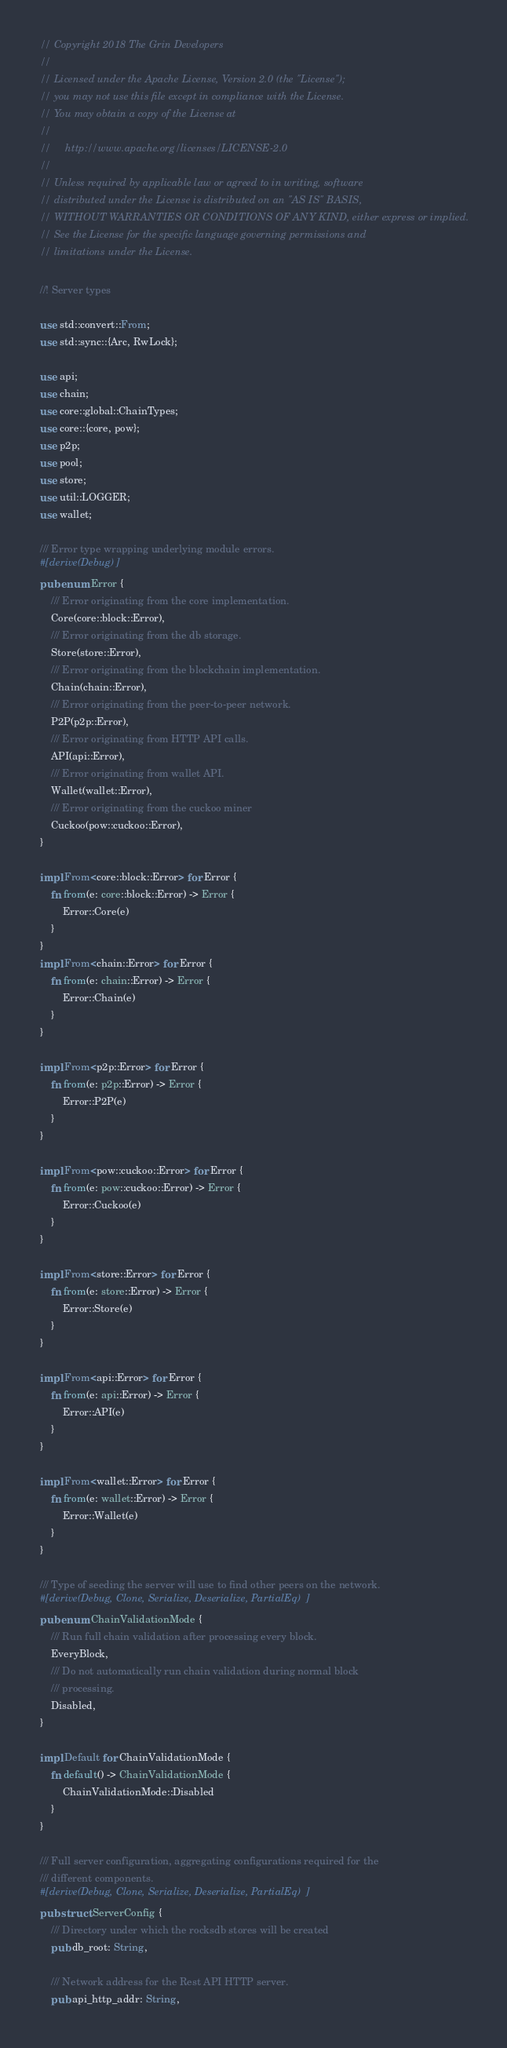<code> <loc_0><loc_0><loc_500><loc_500><_Rust_>// Copyright 2018 The Grin Developers
//
// Licensed under the Apache License, Version 2.0 (the "License");
// you may not use this file except in compliance with the License.
// You may obtain a copy of the License at
//
//     http://www.apache.org/licenses/LICENSE-2.0
//
// Unless required by applicable law or agreed to in writing, software
// distributed under the License is distributed on an "AS IS" BASIS,
// WITHOUT WARRANTIES OR CONDITIONS OF ANY KIND, either express or implied.
// See the License for the specific language governing permissions and
// limitations under the License.

//! Server types

use std::convert::From;
use std::sync::{Arc, RwLock};

use api;
use chain;
use core::global::ChainTypes;
use core::{core, pow};
use p2p;
use pool;
use store;
use util::LOGGER;
use wallet;

/// Error type wrapping underlying module errors.
#[derive(Debug)]
pub enum Error {
	/// Error originating from the core implementation.
	Core(core::block::Error),
	/// Error originating from the db storage.
	Store(store::Error),
	/// Error originating from the blockchain implementation.
	Chain(chain::Error),
	/// Error originating from the peer-to-peer network.
	P2P(p2p::Error),
	/// Error originating from HTTP API calls.
	API(api::Error),
	/// Error originating from wallet API.
	Wallet(wallet::Error),
	/// Error originating from the cuckoo miner
	Cuckoo(pow::cuckoo::Error),
}

impl From<core::block::Error> for Error {
	fn from(e: core::block::Error) -> Error {
		Error::Core(e)
	}
}
impl From<chain::Error> for Error {
	fn from(e: chain::Error) -> Error {
		Error::Chain(e)
	}
}

impl From<p2p::Error> for Error {
	fn from(e: p2p::Error) -> Error {
		Error::P2P(e)
	}
}

impl From<pow::cuckoo::Error> for Error {
	fn from(e: pow::cuckoo::Error) -> Error {
		Error::Cuckoo(e)
	}
}

impl From<store::Error> for Error {
	fn from(e: store::Error) -> Error {
		Error::Store(e)
	}
}

impl From<api::Error> for Error {
	fn from(e: api::Error) -> Error {
		Error::API(e)
	}
}

impl From<wallet::Error> for Error {
	fn from(e: wallet::Error) -> Error {
		Error::Wallet(e)
	}
}

/// Type of seeding the server will use to find other peers on the network.
#[derive(Debug, Clone, Serialize, Deserialize, PartialEq)]
pub enum ChainValidationMode {
	/// Run full chain validation after processing every block.
	EveryBlock,
	/// Do not automatically run chain validation during normal block
	/// processing.
	Disabled,
}

impl Default for ChainValidationMode {
	fn default() -> ChainValidationMode {
		ChainValidationMode::Disabled
	}
}

/// Full server configuration, aggregating configurations required for the
/// different components.
#[derive(Debug, Clone, Serialize, Deserialize, PartialEq)]
pub struct ServerConfig {
	/// Directory under which the rocksdb stores will be created
	pub db_root: String,

	/// Network address for the Rest API HTTP server.
	pub api_http_addr: String,
</code> 